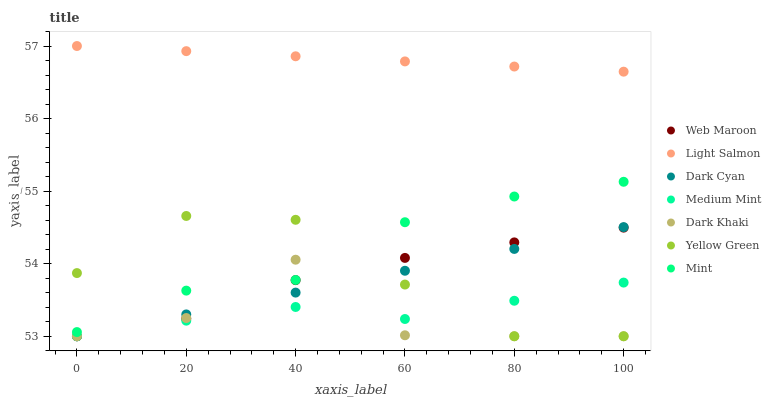Does Dark Khaki have the minimum area under the curve?
Answer yes or no. Yes. Does Light Salmon have the maximum area under the curve?
Answer yes or no. Yes. Does Yellow Green have the minimum area under the curve?
Answer yes or no. No. Does Yellow Green have the maximum area under the curve?
Answer yes or no. No. Is Dark Cyan the smoothest?
Answer yes or no. Yes. Is Dark Khaki the roughest?
Answer yes or no. Yes. Is Light Salmon the smoothest?
Answer yes or no. No. Is Light Salmon the roughest?
Answer yes or no. No. Does Medium Mint have the lowest value?
Answer yes or no. Yes. Does Light Salmon have the lowest value?
Answer yes or no. No. Does Light Salmon have the highest value?
Answer yes or no. Yes. Does Yellow Green have the highest value?
Answer yes or no. No. Is Dark Cyan less than Light Salmon?
Answer yes or no. Yes. Is Light Salmon greater than Mint?
Answer yes or no. Yes. Does Yellow Green intersect Web Maroon?
Answer yes or no. Yes. Is Yellow Green less than Web Maroon?
Answer yes or no. No. Is Yellow Green greater than Web Maroon?
Answer yes or no. No. Does Dark Cyan intersect Light Salmon?
Answer yes or no. No. 